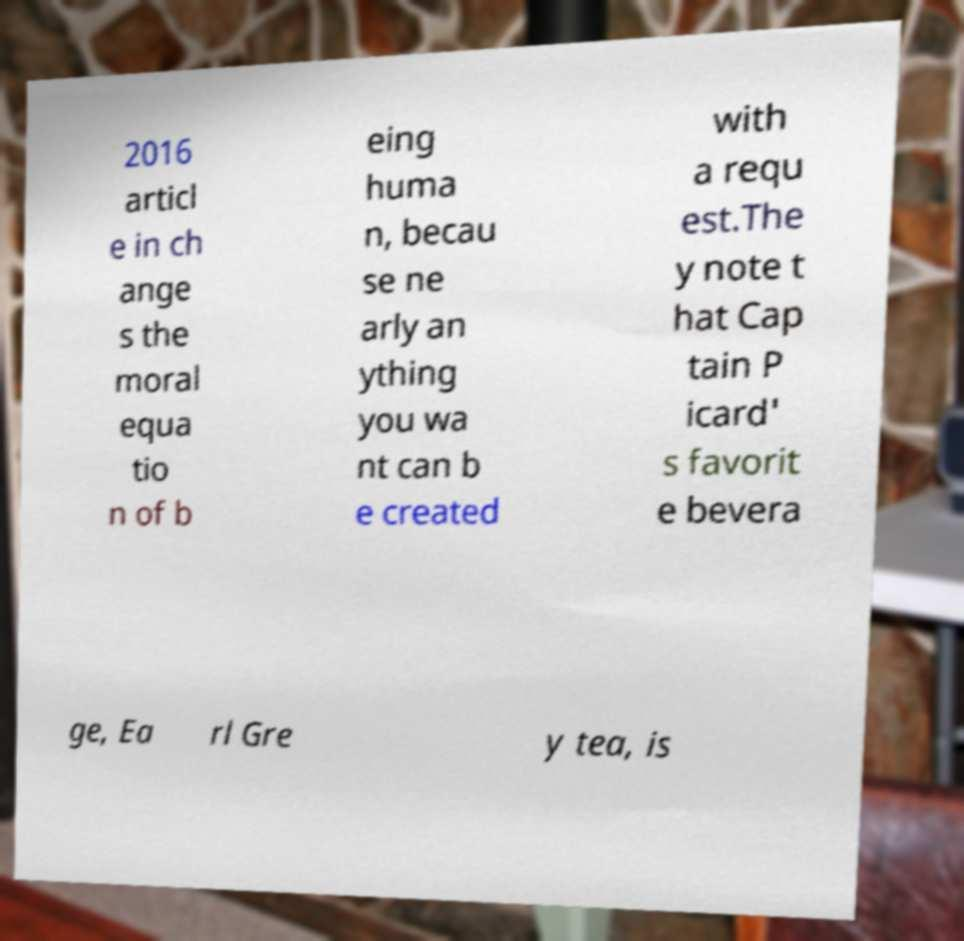Could you extract and type out the text from this image? 2016 articl e in ch ange s the moral equa tio n of b eing huma n, becau se ne arly an ything you wa nt can b e created with a requ est.The y note t hat Cap tain P icard' s favorit e bevera ge, Ea rl Gre y tea, is 